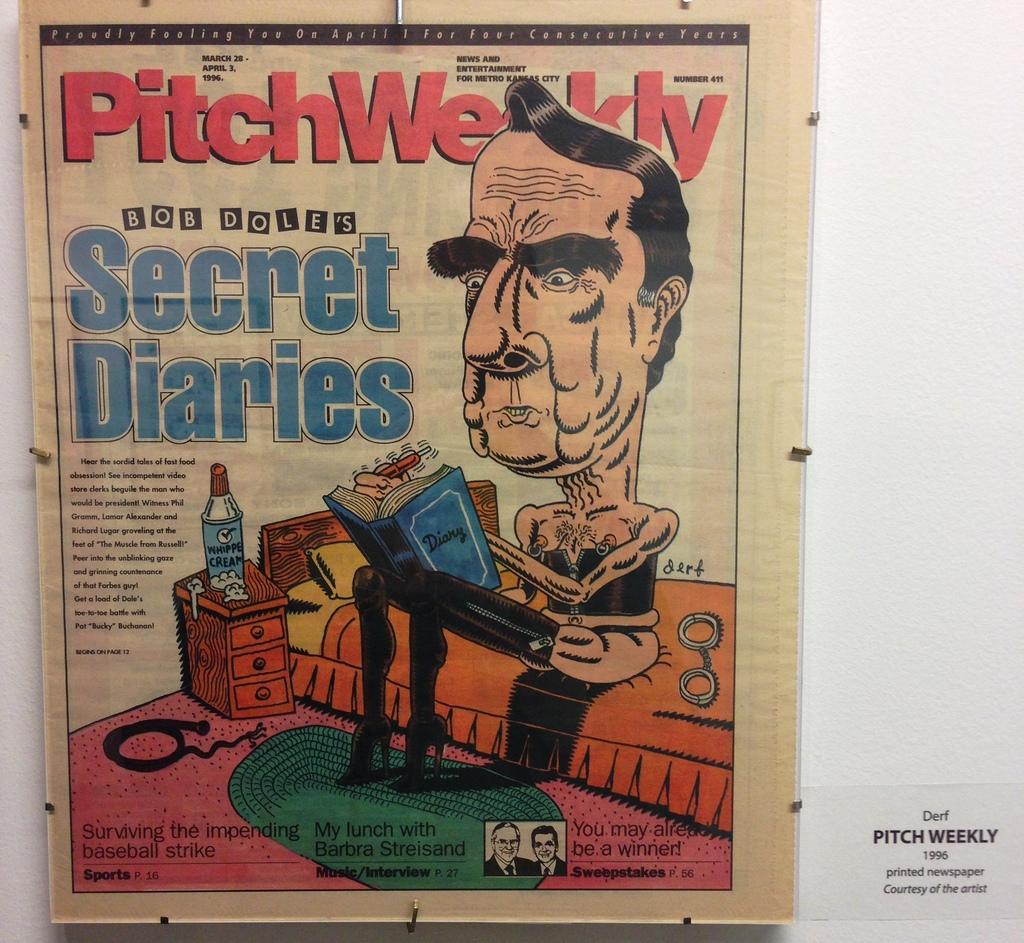Provide a one-sentence caption for the provided image. A newspaper insert called the PitchWeekly Bob Dole's Secret Diaries with a cartoon of Bob Dole sitting on a couch. 